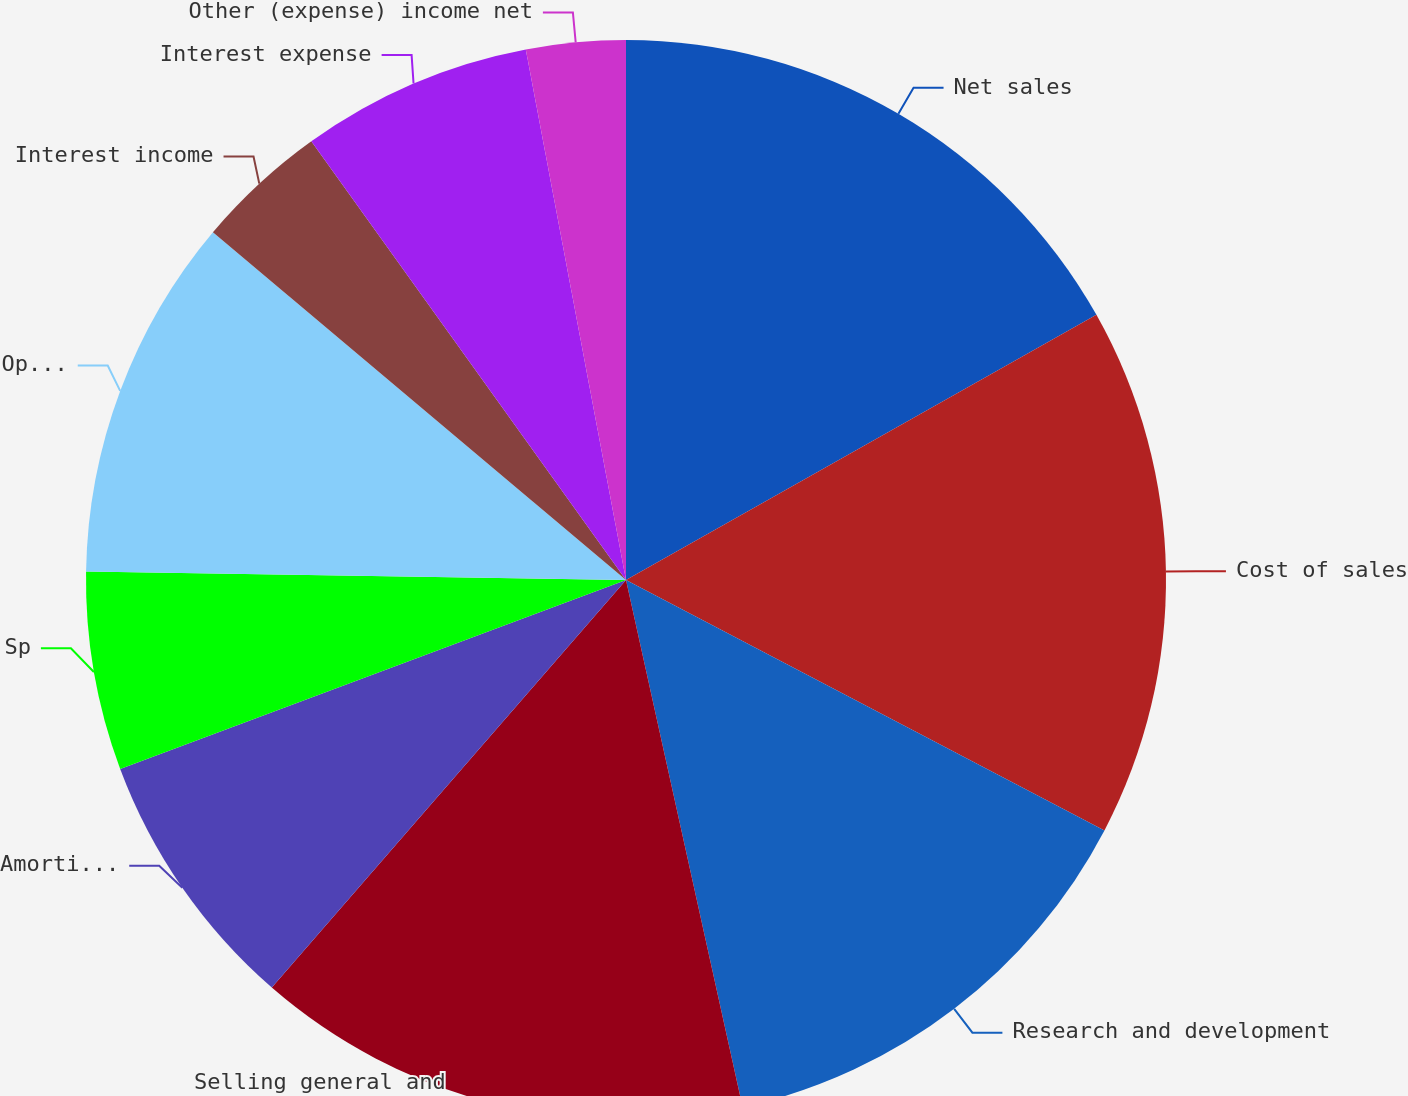Convert chart to OTSL. <chart><loc_0><loc_0><loc_500><loc_500><pie_chart><fcel>Net sales<fcel>Cost of sales<fcel>Research and development<fcel>Selling general and<fcel>Amortization of acquired<fcel>Special charges net (1)<fcel>Operating income<fcel>Interest income<fcel>Interest expense<fcel>Other (expense) income net<nl><fcel>16.83%<fcel>15.84%<fcel>13.86%<fcel>14.85%<fcel>7.92%<fcel>5.94%<fcel>10.89%<fcel>3.96%<fcel>6.93%<fcel>2.97%<nl></chart> 